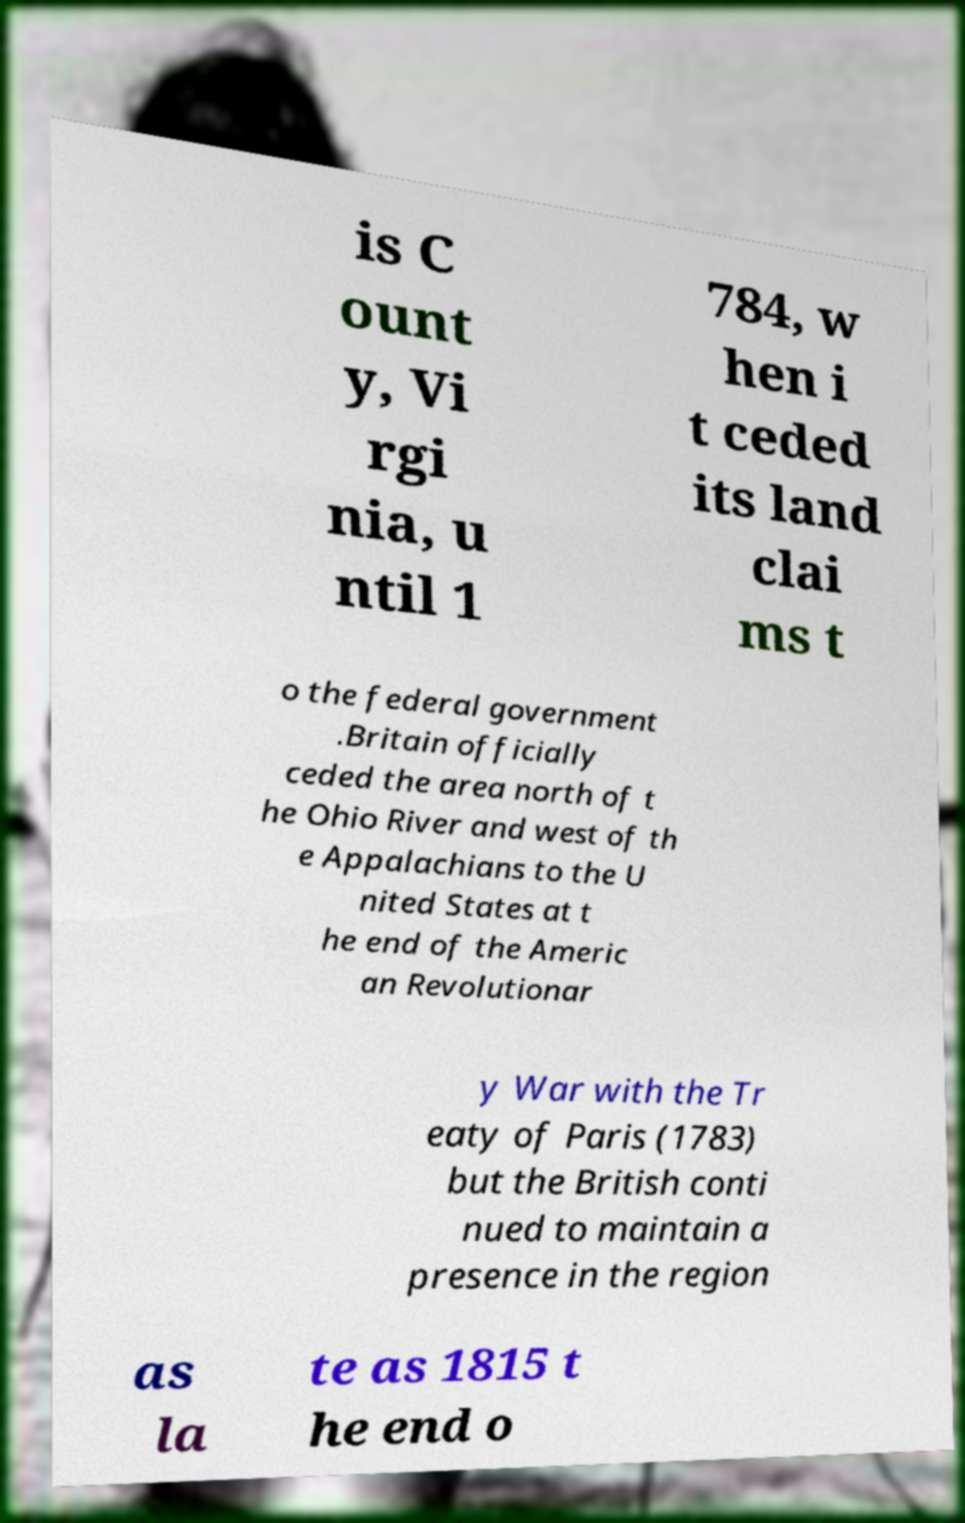Could you assist in decoding the text presented in this image and type it out clearly? is C ount y, Vi rgi nia, u ntil 1 784, w hen i t ceded its land clai ms t o the federal government .Britain officially ceded the area north of t he Ohio River and west of th e Appalachians to the U nited States at t he end of the Americ an Revolutionar y War with the Tr eaty of Paris (1783) but the British conti nued to maintain a presence in the region as la te as 1815 t he end o 